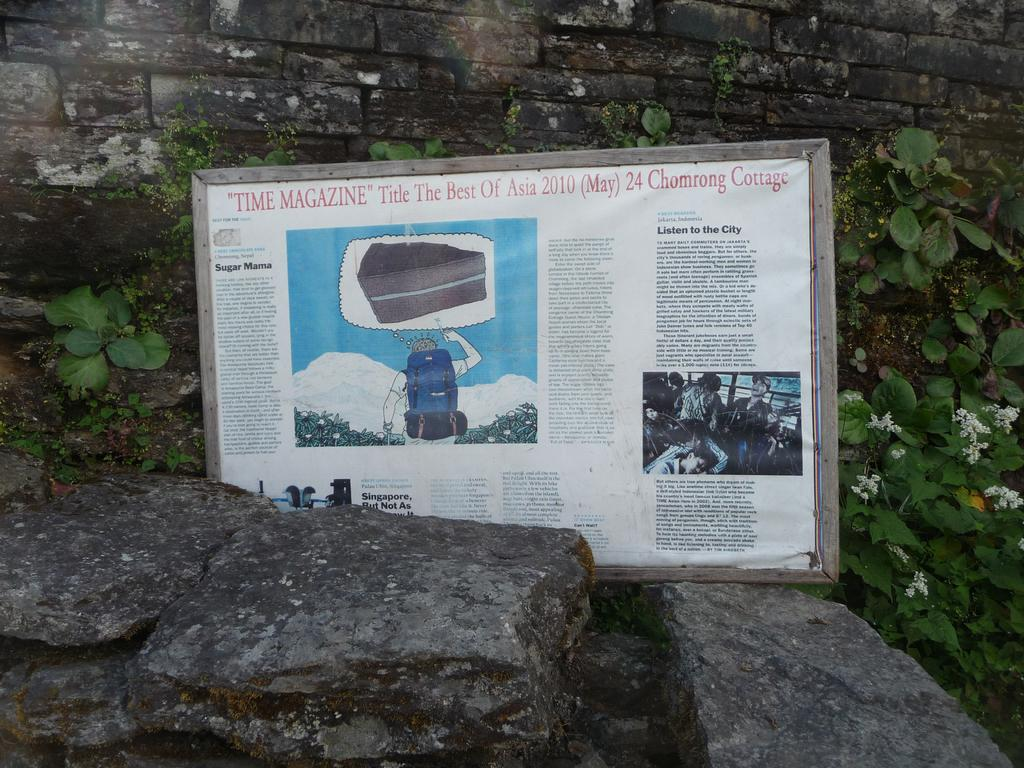What is on the board in the image? There is a poster on the board in the image. What can be found on the poster? The poster contains text and images. What type of objects are present in the image? There are stones, plants, and flowers in the image. What is the background of the image? There is a wall in the image. What type of current can be seen flowing through the pipe in the image? There is no pipe or current present in the image. What type of book is the person reading in the image? There is no person or book visible in the image. 